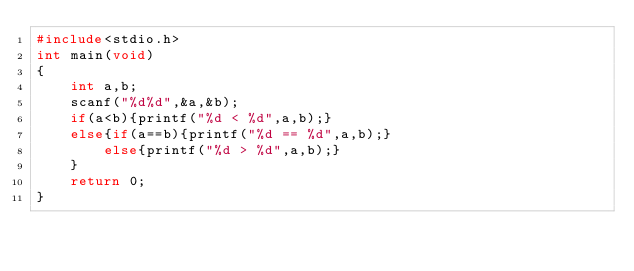<code> <loc_0><loc_0><loc_500><loc_500><_C_>#include<stdio.h>
int main(void)
{
	int a,b;
	scanf("%d%d",&a,&b);
	if(a<b){printf("%d < %d",a,b);}
	else{if(a==b){printf("%d == %d",a,b);}
		else{printf("%d > %d",a,b);}
	}
	return 0;
}</code> 